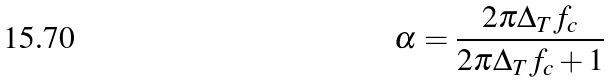Convert formula to latex. <formula><loc_0><loc_0><loc_500><loc_500>\alpha = \frac { 2 \pi \Delta _ { T } f _ { c } } { 2 \pi \Delta _ { T } f _ { c } + 1 }</formula> 